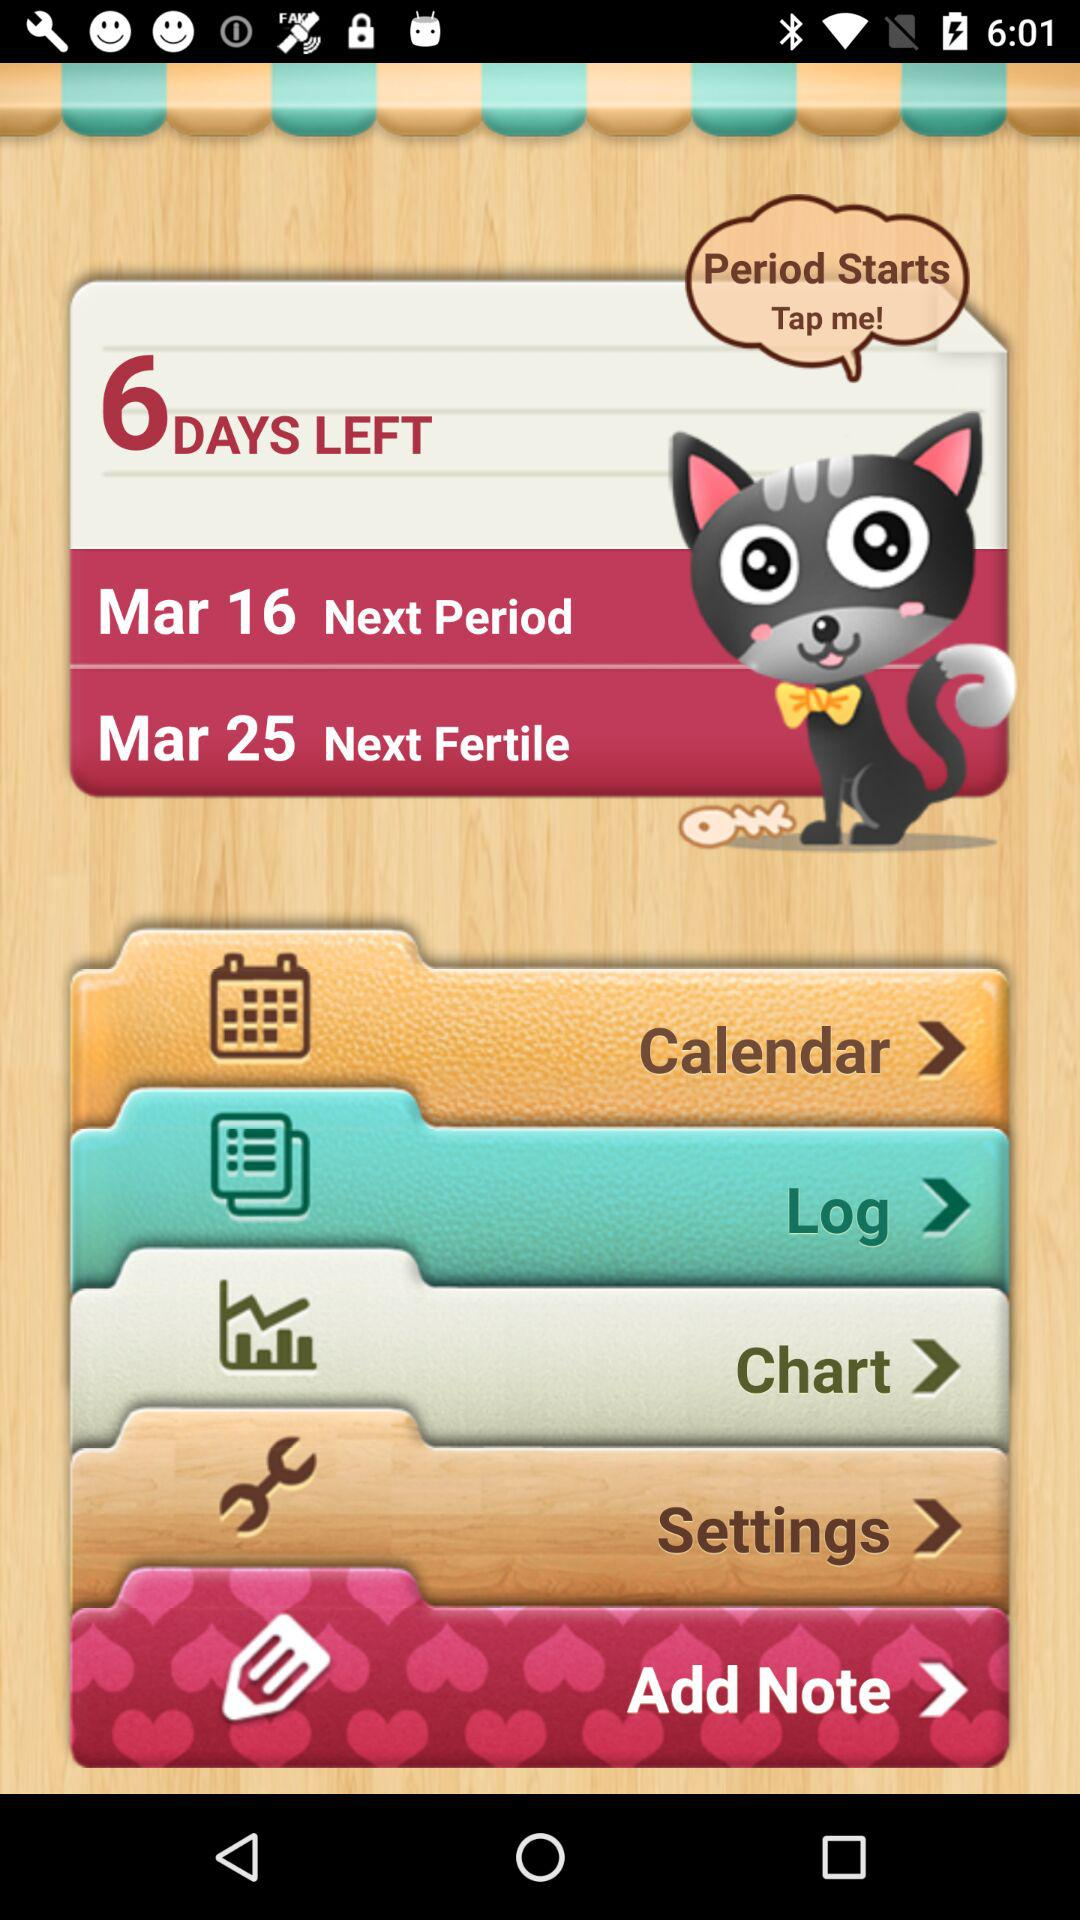What is the next fertile date? The next fertile date is March 25. 